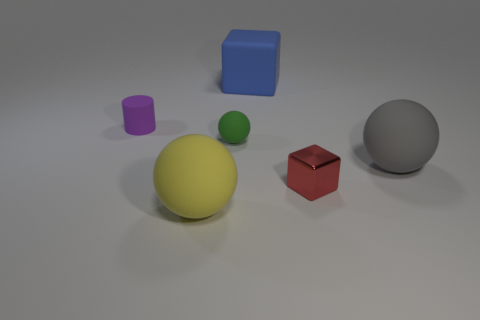Add 1 red cubes. How many objects exist? 7 Subtract all cubes. How many objects are left? 4 Add 1 red metallic objects. How many red metallic objects exist? 2 Subtract 0 yellow blocks. How many objects are left? 6 Subtract all green things. Subtract all small purple things. How many objects are left? 4 Add 6 big gray objects. How many big gray objects are left? 7 